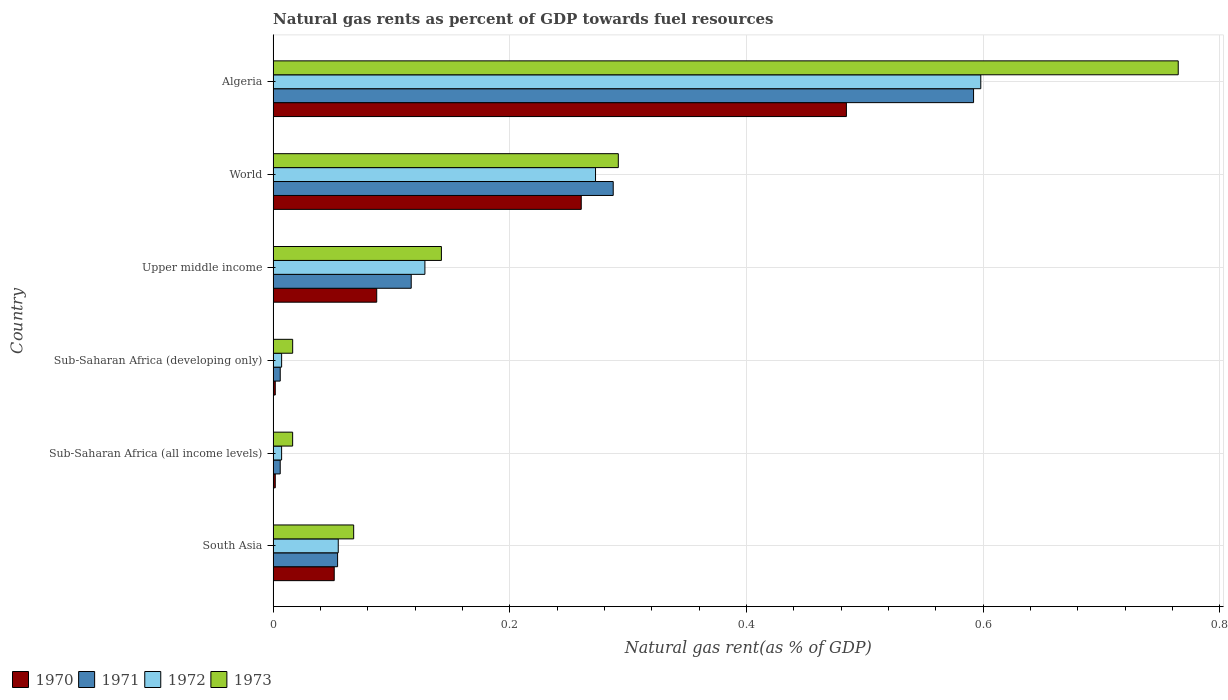How many different coloured bars are there?
Ensure brevity in your answer.  4. How many groups of bars are there?
Offer a terse response. 6. Are the number of bars per tick equal to the number of legend labels?
Your answer should be very brief. Yes. Are the number of bars on each tick of the Y-axis equal?
Offer a terse response. Yes. How many bars are there on the 6th tick from the top?
Ensure brevity in your answer.  4. How many bars are there on the 4th tick from the bottom?
Offer a very short reply. 4. In how many cases, is the number of bars for a given country not equal to the number of legend labels?
Make the answer very short. 0. What is the natural gas rent in 1970 in Sub-Saharan Africa (all income levels)?
Your response must be concise. 0. Across all countries, what is the maximum natural gas rent in 1970?
Ensure brevity in your answer.  0.48. Across all countries, what is the minimum natural gas rent in 1973?
Offer a terse response. 0.02. In which country was the natural gas rent in 1973 maximum?
Offer a very short reply. Algeria. In which country was the natural gas rent in 1971 minimum?
Offer a terse response. Sub-Saharan Africa (all income levels). What is the total natural gas rent in 1971 in the graph?
Provide a succinct answer. 1.06. What is the difference between the natural gas rent in 1970 in South Asia and that in Upper middle income?
Your answer should be compact. -0.04. What is the difference between the natural gas rent in 1973 in Sub-Saharan Africa (all income levels) and the natural gas rent in 1970 in Sub-Saharan Africa (developing only)?
Your answer should be very brief. 0.01. What is the average natural gas rent in 1973 per country?
Make the answer very short. 0.22. What is the difference between the natural gas rent in 1970 and natural gas rent in 1971 in Sub-Saharan Africa (all income levels)?
Provide a short and direct response. -0. In how many countries, is the natural gas rent in 1970 greater than 0.7200000000000001 %?
Ensure brevity in your answer.  0. What is the ratio of the natural gas rent in 1971 in Upper middle income to that in World?
Give a very brief answer. 0.41. What is the difference between the highest and the second highest natural gas rent in 1971?
Your answer should be very brief. 0.3. What is the difference between the highest and the lowest natural gas rent in 1973?
Ensure brevity in your answer.  0.75. Is it the case that in every country, the sum of the natural gas rent in 1973 and natural gas rent in 1972 is greater than the sum of natural gas rent in 1970 and natural gas rent in 1971?
Provide a short and direct response. No. What does the 2nd bar from the top in Sub-Saharan Africa (developing only) represents?
Keep it short and to the point. 1972. What does the 1st bar from the bottom in Sub-Saharan Africa (developing only) represents?
Your response must be concise. 1970. Is it the case that in every country, the sum of the natural gas rent in 1972 and natural gas rent in 1971 is greater than the natural gas rent in 1970?
Your answer should be compact. Yes. How many countries are there in the graph?
Your answer should be compact. 6. What is the difference between two consecutive major ticks on the X-axis?
Make the answer very short. 0.2. Are the values on the major ticks of X-axis written in scientific E-notation?
Your answer should be compact. No. Does the graph contain any zero values?
Offer a terse response. No. What is the title of the graph?
Your response must be concise. Natural gas rents as percent of GDP towards fuel resources. Does "1969" appear as one of the legend labels in the graph?
Ensure brevity in your answer.  No. What is the label or title of the X-axis?
Give a very brief answer. Natural gas rent(as % of GDP). What is the label or title of the Y-axis?
Make the answer very short. Country. What is the Natural gas rent(as % of GDP) in 1970 in South Asia?
Make the answer very short. 0.05. What is the Natural gas rent(as % of GDP) of 1971 in South Asia?
Keep it short and to the point. 0.05. What is the Natural gas rent(as % of GDP) of 1972 in South Asia?
Provide a succinct answer. 0.06. What is the Natural gas rent(as % of GDP) in 1973 in South Asia?
Make the answer very short. 0.07. What is the Natural gas rent(as % of GDP) in 1970 in Sub-Saharan Africa (all income levels)?
Your response must be concise. 0. What is the Natural gas rent(as % of GDP) in 1971 in Sub-Saharan Africa (all income levels)?
Make the answer very short. 0.01. What is the Natural gas rent(as % of GDP) of 1972 in Sub-Saharan Africa (all income levels)?
Give a very brief answer. 0.01. What is the Natural gas rent(as % of GDP) in 1973 in Sub-Saharan Africa (all income levels)?
Make the answer very short. 0.02. What is the Natural gas rent(as % of GDP) in 1970 in Sub-Saharan Africa (developing only)?
Ensure brevity in your answer.  0. What is the Natural gas rent(as % of GDP) in 1971 in Sub-Saharan Africa (developing only)?
Ensure brevity in your answer.  0.01. What is the Natural gas rent(as % of GDP) in 1972 in Sub-Saharan Africa (developing only)?
Give a very brief answer. 0.01. What is the Natural gas rent(as % of GDP) of 1973 in Sub-Saharan Africa (developing only)?
Your response must be concise. 0.02. What is the Natural gas rent(as % of GDP) of 1970 in Upper middle income?
Your answer should be very brief. 0.09. What is the Natural gas rent(as % of GDP) in 1971 in Upper middle income?
Your answer should be compact. 0.12. What is the Natural gas rent(as % of GDP) of 1972 in Upper middle income?
Keep it short and to the point. 0.13. What is the Natural gas rent(as % of GDP) in 1973 in Upper middle income?
Provide a succinct answer. 0.14. What is the Natural gas rent(as % of GDP) of 1970 in World?
Your answer should be very brief. 0.26. What is the Natural gas rent(as % of GDP) in 1971 in World?
Keep it short and to the point. 0.29. What is the Natural gas rent(as % of GDP) in 1972 in World?
Provide a succinct answer. 0.27. What is the Natural gas rent(as % of GDP) in 1973 in World?
Provide a succinct answer. 0.29. What is the Natural gas rent(as % of GDP) of 1970 in Algeria?
Your answer should be very brief. 0.48. What is the Natural gas rent(as % of GDP) in 1971 in Algeria?
Your response must be concise. 0.59. What is the Natural gas rent(as % of GDP) of 1972 in Algeria?
Give a very brief answer. 0.6. What is the Natural gas rent(as % of GDP) in 1973 in Algeria?
Ensure brevity in your answer.  0.76. Across all countries, what is the maximum Natural gas rent(as % of GDP) of 1970?
Keep it short and to the point. 0.48. Across all countries, what is the maximum Natural gas rent(as % of GDP) of 1971?
Make the answer very short. 0.59. Across all countries, what is the maximum Natural gas rent(as % of GDP) of 1972?
Make the answer very short. 0.6. Across all countries, what is the maximum Natural gas rent(as % of GDP) in 1973?
Your response must be concise. 0.76. Across all countries, what is the minimum Natural gas rent(as % of GDP) in 1970?
Offer a very short reply. 0. Across all countries, what is the minimum Natural gas rent(as % of GDP) of 1971?
Provide a succinct answer. 0.01. Across all countries, what is the minimum Natural gas rent(as % of GDP) of 1972?
Give a very brief answer. 0.01. Across all countries, what is the minimum Natural gas rent(as % of GDP) of 1973?
Provide a short and direct response. 0.02. What is the total Natural gas rent(as % of GDP) of 1970 in the graph?
Give a very brief answer. 0.89. What is the total Natural gas rent(as % of GDP) of 1972 in the graph?
Keep it short and to the point. 1.07. What is the total Natural gas rent(as % of GDP) in 1973 in the graph?
Your answer should be compact. 1.3. What is the difference between the Natural gas rent(as % of GDP) of 1970 in South Asia and that in Sub-Saharan Africa (all income levels)?
Offer a terse response. 0.05. What is the difference between the Natural gas rent(as % of GDP) in 1971 in South Asia and that in Sub-Saharan Africa (all income levels)?
Offer a very short reply. 0.05. What is the difference between the Natural gas rent(as % of GDP) of 1972 in South Asia and that in Sub-Saharan Africa (all income levels)?
Provide a succinct answer. 0.05. What is the difference between the Natural gas rent(as % of GDP) of 1973 in South Asia and that in Sub-Saharan Africa (all income levels)?
Provide a short and direct response. 0.05. What is the difference between the Natural gas rent(as % of GDP) in 1970 in South Asia and that in Sub-Saharan Africa (developing only)?
Give a very brief answer. 0.05. What is the difference between the Natural gas rent(as % of GDP) in 1971 in South Asia and that in Sub-Saharan Africa (developing only)?
Give a very brief answer. 0.05. What is the difference between the Natural gas rent(as % of GDP) of 1972 in South Asia and that in Sub-Saharan Africa (developing only)?
Provide a short and direct response. 0.05. What is the difference between the Natural gas rent(as % of GDP) in 1973 in South Asia and that in Sub-Saharan Africa (developing only)?
Your response must be concise. 0.05. What is the difference between the Natural gas rent(as % of GDP) in 1970 in South Asia and that in Upper middle income?
Provide a succinct answer. -0.04. What is the difference between the Natural gas rent(as % of GDP) of 1971 in South Asia and that in Upper middle income?
Your answer should be very brief. -0.06. What is the difference between the Natural gas rent(as % of GDP) in 1972 in South Asia and that in Upper middle income?
Offer a very short reply. -0.07. What is the difference between the Natural gas rent(as % of GDP) of 1973 in South Asia and that in Upper middle income?
Offer a terse response. -0.07. What is the difference between the Natural gas rent(as % of GDP) in 1970 in South Asia and that in World?
Your response must be concise. -0.21. What is the difference between the Natural gas rent(as % of GDP) in 1971 in South Asia and that in World?
Provide a succinct answer. -0.23. What is the difference between the Natural gas rent(as % of GDP) in 1972 in South Asia and that in World?
Provide a succinct answer. -0.22. What is the difference between the Natural gas rent(as % of GDP) of 1973 in South Asia and that in World?
Your answer should be compact. -0.22. What is the difference between the Natural gas rent(as % of GDP) of 1970 in South Asia and that in Algeria?
Keep it short and to the point. -0.43. What is the difference between the Natural gas rent(as % of GDP) of 1971 in South Asia and that in Algeria?
Your response must be concise. -0.54. What is the difference between the Natural gas rent(as % of GDP) of 1972 in South Asia and that in Algeria?
Keep it short and to the point. -0.54. What is the difference between the Natural gas rent(as % of GDP) of 1973 in South Asia and that in Algeria?
Make the answer very short. -0.7. What is the difference between the Natural gas rent(as % of GDP) of 1972 in Sub-Saharan Africa (all income levels) and that in Sub-Saharan Africa (developing only)?
Provide a succinct answer. -0. What is the difference between the Natural gas rent(as % of GDP) of 1970 in Sub-Saharan Africa (all income levels) and that in Upper middle income?
Ensure brevity in your answer.  -0.09. What is the difference between the Natural gas rent(as % of GDP) of 1971 in Sub-Saharan Africa (all income levels) and that in Upper middle income?
Ensure brevity in your answer.  -0.11. What is the difference between the Natural gas rent(as % of GDP) of 1972 in Sub-Saharan Africa (all income levels) and that in Upper middle income?
Provide a succinct answer. -0.12. What is the difference between the Natural gas rent(as % of GDP) of 1973 in Sub-Saharan Africa (all income levels) and that in Upper middle income?
Ensure brevity in your answer.  -0.13. What is the difference between the Natural gas rent(as % of GDP) of 1970 in Sub-Saharan Africa (all income levels) and that in World?
Make the answer very short. -0.26. What is the difference between the Natural gas rent(as % of GDP) of 1971 in Sub-Saharan Africa (all income levels) and that in World?
Provide a succinct answer. -0.28. What is the difference between the Natural gas rent(as % of GDP) of 1972 in Sub-Saharan Africa (all income levels) and that in World?
Provide a succinct answer. -0.27. What is the difference between the Natural gas rent(as % of GDP) in 1973 in Sub-Saharan Africa (all income levels) and that in World?
Give a very brief answer. -0.28. What is the difference between the Natural gas rent(as % of GDP) in 1970 in Sub-Saharan Africa (all income levels) and that in Algeria?
Offer a very short reply. -0.48. What is the difference between the Natural gas rent(as % of GDP) of 1971 in Sub-Saharan Africa (all income levels) and that in Algeria?
Provide a short and direct response. -0.59. What is the difference between the Natural gas rent(as % of GDP) in 1972 in Sub-Saharan Africa (all income levels) and that in Algeria?
Provide a succinct answer. -0.59. What is the difference between the Natural gas rent(as % of GDP) in 1973 in Sub-Saharan Africa (all income levels) and that in Algeria?
Make the answer very short. -0.75. What is the difference between the Natural gas rent(as % of GDP) of 1970 in Sub-Saharan Africa (developing only) and that in Upper middle income?
Your answer should be very brief. -0.09. What is the difference between the Natural gas rent(as % of GDP) in 1971 in Sub-Saharan Africa (developing only) and that in Upper middle income?
Offer a very short reply. -0.11. What is the difference between the Natural gas rent(as % of GDP) in 1972 in Sub-Saharan Africa (developing only) and that in Upper middle income?
Make the answer very short. -0.12. What is the difference between the Natural gas rent(as % of GDP) in 1973 in Sub-Saharan Africa (developing only) and that in Upper middle income?
Offer a very short reply. -0.13. What is the difference between the Natural gas rent(as % of GDP) in 1970 in Sub-Saharan Africa (developing only) and that in World?
Your answer should be compact. -0.26. What is the difference between the Natural gas rent(as % of GDP) in 1971 in Sub-Saharan Africa (developing only) and that in World?
Offer a terse response. -0.28. What is the difference between the Natural gas rent(as % of GDP) in 1972 in Sub-Saharan Africa (developing only) and that in World?
Keep it short and to the point. -0.27. What is the difference between the Natural gas rent(as % of GDP) of 1973 in Sub-Saharan Africa (developing only) and that in World?
Keep it short and to the point. -0.28. What is the difference between the Natural gas rent(as % of GDP) in 1970 in Sub-Saharan Africa (developing only) and that in Algeria?
Offer a very short reply. -0.48. What is the difference between the Natural gas rent(as % of GDP) of 1971 in Sub-Saharan Africa (developing only) and that in Algeria?
Make the answer very short. -0.59. What is the difference between the Natural gas rent(as % of GDP) in 1972 in Sub-Saharan Africa (developing only) and that in Algeria?
Keep it short and to the point. -0.59. What is the difference between the Natural gas rent(as % of GDP) of 1973 in Sub-Saharan Africa (developing only) and that in Algeria?
Your answer should be very brief. -0.75. What is the difference between the Natural gas rent(as % of GDP) in 1970 in Upper middle income and that in World?
Ensure brevity in your answer.  -0.17. What is the difference between the Natural gas rent(as % of GDP) of 1971 in Upper middle income and that in World?
Make the answer very short. -0.17. What is the difference between the Natural gas rent(as % of GDP) in 1972 in Upper middle income and that in World?
Offer a very short reply. -0.14. What is the difference between the Natural gas rent(as % of GDP) in 1973 in Upper middle income and that in World?
Provide a succinct answer. -0.15. What is the difference between the Natural gas rent(as % of GDP) in 1970 in Upper middle income and that in Algeria?
Provide a succinct answer. -0.4. What is the difference between the Natural gas rent(as % of GDP) of 1971 in Upper middle income and that in Algeria?
Your response must be concise. -0.48. What is the difference between the Natural gas rent(as % of GDP) of 1972 in Upper middle income and that in Algeria?
Your answer should be compact. -0.47. What is the difference between the Natural gas rent(as % of GDP) in 1973 in Upper middle income and that in Algeria?
Provide a short and direct response. -0.62. What is the difference between the Natural gas rent(as % of GDP) in 1970 in World and that in Algeria?
Ensure brevity in your answer.  -0.22. What is the difference between the Natural gas rent(as % of GDP) in 1971 in World and that in Algeria?
Keep it short and to the point. -0.3. What is the difference between the Natural gas rent(as % of GDP) in 1972 in World and that in Algeria?
Ensure brevity in your answer.  -0.33. What is the difference between the Natural gas rent(as % of GDP) in 1973 in World and that in Algeria?
Give a very brief answer. -0.47. What is the difference between the Natural gas rent(as % of GDP) of 1970 in South Asia and the Natural gas rent(as % of GDP) of 1971 in Sub-Saharan Africa (all income levels)?
Ensure brevity in your answer.  0.05. What is the difference between the Natural gas rent(as % of GDP) in 1970 in South Asia and the Natural gas rent(as % of GDP) in 1972 in Sub-Saharan Africa (all income levels)?
Give a very brief answer. 0.04. What is the difference between the Natural gas rent(as % of GDP) of 1970 in South Asia and the Natural gas rent(as % of GDP) of 1973 in Sub-Saharan Africa (all income levels)?
Your response must be concise. 0.04. What is the difference between the Natural gas rent(as % of GDP) of 1971 in South Asia and the Natural gas rent(as % of GDP) of 1972 in Sub-Saharan Africa (all income levels)?
Your response must be concise. 0.05. What is the difference between the Natural gas rent(as % of GDP) of 1971 in South Asia and the Natural gas rent(as % of GDP) of 1973 in Sub-Saharan Africa (all income levels)?
Your answer should be compact. 0.04. What is the difference between the Natural gas rent(as % of GDP) of 1972 in South Asia and the Natural gas rent(as % of GDP) of 1973 in Sub-Saharan Africa (all income levels)?
Ensure brevity in your answer.  0.04. What is the difference between the Natural gas rent(as % of GDP) of 1970 in South Asia and the Natural gas rent(as % of GDP) of 1971 in Sub-Saharan Africa (developing only)?
Offer a very short reply. 0.05. What is the difference between the Natural gas rent(as % of GDP) in 1970 in South Asia and the Natural gas rent(as % of GDP) in 1972 in Sub-Saharan Africa (developing only)?
Ensure brevity in your answer.  0.04. What is the difference between the Natural gas rent(as % of GDP) in 1970 in South Asia and the Natural gas rent(as % of GDP) in 1973 in Sub-Saharan Africa (developing only)?
Your answer should be very brief. 0.04. What is the difference between the Natural gas rent(as % of GDP) in 1971 in South Asia and the Natural gas rent(as % of GDP) in 1972 in Sub-Saharan Africa (developing only)?
Offer a very short reply. 0.05. What is the difference between the Natural gas rent(as % of GDP) of 1971 in South Asia and the Natural gas rent(as % of GDP) of 1973 in Sub-Saharan Africa (developing only)?
Make the answer very short. 0.04. What is the difference between the Natural gas rent(as % of GDP) in 1972 in South Asia and the Natural gas rent(as % of GDP) in 1973 in Sub-Saharan Africa (developing only)?
Provide a short and direct response. 0.04. What is the difference between the Natural gas rent(as % of GDP) of 1970 in South Asia and the Natural gas rent(as % of GDP) of 1971 in Upper middle income?
Ensure brevity in your answer.  -0.07. What is the difference between the Natural gas rent(as % of GDP) of 1970 in South Asia and the Natural gas rent(as % of GDP) of 1972 in Upper middle income?
Provide a succinct answer. -0.08. What is the difference between the Natural gas rent(as % of GDP) of 1970 in South Asia and the Natural gas rent(as % of GDP) of 1973 in Upper middle income?
Provide a short and direct response. -0.09. What is the difference between the Natural gas rent(as % of GDP) of 1971 in South Asia and the Natural gas rent(as % of GDP) of 1972 in Upper middle income?
Your answer should be compact. -0.07. What is the difference between the Natural gas rent(as % of GDP) of 1971 in South Asia and the Natural gas rent(as % of GDP) of 1973 in Upper middle income?
Give a very brief answer. -0.09. What is the difference between the Natural gas rent(as % of GDP) of 1972 in South Asia and the Natural gas rent(as % of GDP) of 1973 in Upper middle income?
Your response must be concise. -0.09. What is the difference between the Natural gas rent(as % of GDP) in 1970 in South Asia and the Natural gas rent(as % of GDP) in 1971 in World?
Ensure brevity in your answer.  -0.24. What is the difference between the Natural gas rent(as % of GDP) in 1970 in South Asia and the Natural gas rent(as % of GDP) in 1972 in World?
Your answer should be very brief. -0.22. What is the difference between the Natural gas rent(as % of GDP) of 1970 in South Asia and the Natural gas rent(as % of GDP) of 1973 in World?
Provide a succinct answer. -0.24. What is the difference between the Natural gas rent(as % of GDP) of 1971 in South Asia and the Natural gas rent(as % of GDP) of 1972 in World?
Your response must be concise. -0.22. What is the difference between the Natural gas rent(as % of GDP) in 1971 in South Asia and the Natural gas rent(as % of GDP) in 1973 in World?
Provide a succinct answer. -0.24. What is the difference between the Natural gas rent(as % of GDP) of 1972 in South Asia and the Natural gas rent(as % of GDP) of 1973 in World?
Your answer should be compact. -0.24. What is the difference between the Natural gas rent(as % of GDP) in 1970 in South Asia and the Natural gas rent(as % of GDP) in 1971 in Algeria?
Your response must be concise. -0.54. What is the difference between the Natural gas rent(as % of GDP) in 1970 in South Asia and the Natural gas rent(as % of GDP) in 1972 in Algeria?
Your answer should be compact. -0.55. What is the difference between the Natural gas rent(as % of GDP) in 1970 in South Asia and the Natural gas rent(as % of GDP) in 1973 in Algeria?
Offer a terse response. -0.71. What is the difference between the Natural gas rent(as % of GDP) in 1971 in South Asia and the Natural gas rent(as % of GDP) in 1972 in Algeria?
Give a very brief answer. -0.54. What is the difference between the Natural gas rent(as % of GDP) in 1971 in South Asia and the Natural gas rent(as % of GDP) in 1973 in Algeria?
Keep it short and to the point. -0.71. What is the difference between the Natural gas rent(as % of GDP) in 1972 in South Asia and the Natural gas rent(as % of GDP) in 1973 in Algeria?
Make the answer very short. -0.71. What is the difference between the Natural gas rent(as % of GDP) of 1970 in Sub-Saharan Africa (all income levels) and the Natural gas rent(as % of GDP) of 1971 in Sub-Saharan Africa (developing only)?
Ensure brevity in your answer.  -0. What is the difference between the Natural gas rent(as % of GDP) of 1970 in Sub-Saharan Africa (all income levels) and the Natural gas rent(as % of GDP) of 1972 in Sub-Saharan Africa (developing only)?
Ensure brevity in your answer.  -0.01. What is the difference between the Natural gas rent(as % of GDP) of 1970 in Sub-Saharan Africa (all income levels) and the Natural gas rent(as % of GDP) of 1973 in Sub-Saharan Africa (developing only)?
Offer a very short reply. -0.01. What is the difference between the Natural gas rent(as % of GDP) in 1971 in Sub-Saharan Africa (all income levels) and the Natural gas rent(as % of GDP) in 1972 in Sub-Saharan Africa (developing only)?
Provide a succinct answer. -0. What is the difference between the Natural gas rent(as % of GDP) of 1971 in Sub-Saharan Africa (all income levels) and the Natural gas rent(as % of GDP) of 1973 in Sub-Saharan Africa (developing only)?
Your answer should be very brief. -0.01. What is the difference between the Natural gas rent(as % of GDP) of 1972 in Sub-Saharan Africa (all income levels) and the Natural gas rent(as % of GDP) of 1973 in Sub-Saharan Africa (developing only)?
Give a very brief answer. -0.01. What is the difference between the Natural gas rent(as % of GDP) of 1970 in Sub-Saharan Africa (all income levels) and the Natural gas rent(as % of GDP) of 1971 in Upper middle income?
Make the answer very short. -0.11. What is the difference between the Natural gas rent(as % of GDP) in 1970 in Sub-Saharan Africa (all income levels) and the Natural gas rent(as % of GDP) in 1972 in Upper middle income?
Your answer should be very brief. -0.13. What is the difference between the Natural gas rent(as % of GDP) in 1970 in Sub-Saharan Africa (all income levels) and the Natural gas rent(as % of GDP) in 1973 in Upper middle income?
Ensure brevity in your answer.  -0.14. What is the difference between the Natural gas rent(as % of GDP) in 1971 in Sub-Saharan Africa (all income levels) and the Natural gas rent(as % of GDP) in 1972 in Upper middle income?
Your answer should be very brief. -0.12. What is the difference between the Natural gas rent(as % of GDP) of 1971 in Sub-Saharan Africa (all income levels) and the Natural gas rent(as % of GDP) of 1973 in Upper middle income?
Make the answer very short. -0.14. What is the difference between the Natural gas rent(as % of GDP) of 1972 in Sub-Saharan Africa (all income levels) and the Natural gas rent(as % of GDP) of 1973 in Upper middle income?
Provide a short and direct response. -0.14. What is the difference between the Natural gas rent(as % of GDP) in 1970 in Sub-Saharan Africa (all income levels) and the Natural gas rent(as % of GDP) in 1971 in World?
Offer a terse response. -0.29. What is the difference between the Natural gas rent(as % of GDP) of 1970 in Sub-Saharan Africa (all income levels) and the Natural gas rent(as % of GDP) of 1972 in World?
Ensure brevity in your answer.  -0.27. What is the difference between the Natural gas rent(as % of GDP) in 1970 in Sub-Saharan Africa (all income levels) and the Natural gas rent(as % of GDP) in 1973 in World?
Give a very brief answer. -0.29. What is the difference between the Natural gas rent(as % of GDP) of 1971 in Sub-Saharan Africa (all income levels) and the Natural gas rent(as % of GDP) of 1972 in World?
Provide a succinct answer. -0.27. What is the difference between the Natural gas rent(as % of GDP) in 1971 in Sub-Saharan Africa (all income levels) and the Natural gas rent(as % of GDP) in 1973 in World?
Your response must be concise. -0.29. What is the difference between the Natural gas rent(as % of GDP) of 1972 in Sub-Saharan Africa (all income levels) and the Natural gas rent(as % of GDP) of 1973 in World?
Ensure brevity in your answer.  -0.28. What is the difference between the Natural gas rent(as % of GDP) of 1970 in Sub-Saharan Africa (all income levels) and the Natural gas rent(as % of GDP) of 1971 in Algeria?
Offer a very short reply. -0.59. What is the difference between the Natural gas rent(as % of GDP) of 1970 in Sub-Saharan Africa (all income levels) and the Natural gas rent(as % of GDP) of 1972 in Algeria?
Provide a short and direct response. -0.6. What is the difference between the Natural gas rent(as % of GDP) in 1970 in Sub-Saharan Africa (all income levels) and the Natural gas rent(as % of GDP) in 1973 in Algeria?
Ensure brevity in your answer.  -0.76. What is the difference between the Natural gas rent(as % of GDP) of 1971 in Sub-Saharan Africa (all income levels) and the Natural gas rent(as % of GDP) of 1972 in Algeria?
Give a very brief answer. -0.59. What is the difference between the Natural gas rent(as % of GDP) in 1971 in Sub-Saharan Africa (all income levels) and the Natural gas rent(as % of GDP) in 1973 in Algeria?
Ensure brevity in your answer.  -0.76. What is the difference between the Natural gas rent(as % of GDP) in 1972 in Sub-Saharan Africa (all income levels) and the Natural gas rent(as % of GDP) in 1973 in Algeria?
Keep it short and to the point. -0.76. What is the difference between the Natural gas rent(as % of GDP) of 1970 in Sub-Saharan Africa (developing only) and the Natural gas rent(as % of GDP) of 1971 in Upper middle income?
Give a very brief answer. -0.11. What is the difference between the Natural gas rent(as % of GDP) of 1970 in Sub-Saharan Africa (developing only) and the Natural gas rent(as % of GDP) of 1972 in Upper middle income?
Offer a very short reply. -0.13. What is the difference between the Natural gas rent(as % of GDP) of 1970 in Sub-Saharan Africa (developing only) and the Natural gas rent(as % of GDP) of 1973 in Upper middle income?
Offer a very short reply. -0.14. What is the difference between the Natural gas rent(as % of GDP) in 1971 in Sub-Saharan Africa (developing only) and the Natural gas rent(as % of GDP) in 1972 in Upper middle income?
Offer a terse response. -0.12. What is the difference between the Natural gas rent(as % of GDP) in 1971 in Sub-Saharan Africa (developing only) and the Natural gas rent(as % of GDP) in 1973 in Upper middle income?
Offer a terse response. -0.14. What is the difference between the Natural gas rent(as % of GDP) of 1972 in Sub-Saharan Africa (developing only) and the Natural gas rent(as % of GDP) of 1973 in Upper middle income?
Keep it short and to the point. -0.14. What is the difference between the Natural gas rent(as % of GDP) of 1970 in Sub-Saharan Africa (developing only) and the Natural gas rent(as % of GDP) of 1971 in World?
Offer a very short reply. -0.29. What is the difference between the Natural gas rent(as % of GDP) in 1970 in Sub-Saharan Africa (developing only) and the Natural gas rent(as % of GDP) in 1972 in World?
Provide a succinct answer. -0.27. What is the difference between the Natural gas rent(as % of GDP) of 1970 in Sub-Saharan Africa (developing only) and the Natural gas rent(as % of GDP) of 1973 in World?
Your answer should be compact. -0.29. What is the difference between the Natural gas rent(as % of GDP) in 1971 in Sub-Saharan Africa (developing only) and the Natural gas rent(as % of GDP) in 1972 in World?
Ensure brevity in your answer.  -0.27. What is the difference between the Natural gas rent(as % of GDP) in 1971 in Sub-Saharan Africa (developing only) and the Natural gas rent(as % of GDP) in 1973 in World?
Keep it short and to the point. -0.29. What is the difference between the Natural gas rent(as % of GDP) in 1972 in Sub-Saharan Africa (developing only) and the Natural gas rent(as % of GDP) in 1973 in World?
Your answer should be very brief. -0.28. What is the difference between the Natural gas rent(as % of GDP) in 1970 in Sub-Saharan Africa (developing only) and the Natural gas rent(as % of GDP) in 1971 in Algeria?
Offer a very short reply. -0.59. What is the difference between the Natural gas rent(as % of GDP) of 1970 in Sub-Saharan Africa (developing only) and the Natural gas rent(as % of GDP) of 1972 in Algeria?
Ensure brevity in your answer.  -0.6. What is the difference between the Natural gas rent(as % of GDP) of 1970 in Sub-Saharan Africa (developing only) and the Natural gas rent(as % of GDP) of 1973 in Algeria?
Your answer should be compact. -0.76. What is the difference between the Natural gas rent(as % of GDP) of 1971 in Sub-Saharan Africa (developing only) and the Natural gas rent(as % of GDP) of 1972 in Algeria?
Keep it short and to the point. -0.59. What is the difference between the Natural gas rent(as % of GDP) in 1971 in Sub-Saharan Africa (developing only) and the Natural gas rent(as % of GDP) in 1973 in Algeria?
Offer a very short reply. -0.76. What is the difference between the Natural gas rent(as % of GDP) in 1972 in Sub-Saharan Africa (developing only) and the Natural gas rent(as % of GDP) in 1973 in Algeria?
Give a very brief answer. -0.76. What is the difference between the Natural gas rent(as % of GDP) in 1970 in Upper middle income and the Natural gas rent(as % of GDP) in 1971 in World?
Your answer should be very brief. -0.2. What is the difference between the Natural gas rent(as % of GDP) of 1970 in Upper middle income and the Natural gas rent(as % of GDP) of 1972 in World?
Make the answer very short. -0.18. What is the difference between the Natural gas rent(as % of GDP) in 1970 in Upper middle income and the Natural gas rent(as % of GDP) in 1973 in World?
Your answer should be very brief. -0.2. What is the difference between the Natural gas rent(as % of GDP) in 1971 in Upper middle income and the Natural gas rent(as % of GDP) in 1972 in World?
Your response must be concise. -0.16. What is the difference between the Natural gas rent(as % of GDP) in 1971 in Upper middle income and the Natural gas rent(as % of GDP) in 1973 in World?
Offer a terse response. -0.17. What is the difference between the Natural gas rent(as % of GDP) in 1972 in Upper middle income and the Natural gas rent(as % of GDP) in 1973 in World?
Give a very brief answer. -0.16. What is the difference between the Natural gas rent(as % of GDP) of 1970 in Upper middle income and the Natural gas rent(as % of GDP) of 1971 in Algeria?
Provide a short and direct response. -0.5. What is the difference between the Natural gas rent(as % of GDP) in 1970 in Upper middle income and the Natural gas rent(as % of GDP) in 1972 in Algeria?
Provide a short and direct response. -0.51. What is the difference between the Natural gas rent(as % of GDP) in 1970 in Upper middle income and the Natural gas rent(as % of GDP) in 1973 in Algeria?
Your answer should be compact. -0.68. What is the difference between the Natural gas rent(as % of GDP) in 1971 in Upper middle income and the Natural gas rent(as % of GDP) in 1972 in Algeria?
Ensure brevity in your answer.  -0.48. What is the difference between the Natural gas rent(as % of GDP) in 1971 in Upper middle income and the Natural gas rent(as % of GDP) in 1973 in Algeria?
Offer a terse response. -0.65. What is the difference between the Natural gas rent(as % of GDP) in 1972 in Upper middle income and the Natural gas rent(as % of GDP) in 1973 in Algeria?
Your answer should be compact. -0.64. What is the difference between the Natural gas rent(as % of GDP) of 1970 in World and the Natural gas rent(as % of GDP) of 1971 in Algeria?
Provide a succinct answer. -0.33. What is the difference between the Natural gas rent(as % of GDP) of 1970 in World and the Natural gas rent(as % of GDP) of 1972 in Algeria?
Keep it short and to the point. -0.34. What is the difference between the Natural gas rent(as % of GDP) of 1970 in World and the Natural gas rent(as % of GDP) of 1973 in Algeria?
Make the answer very short. -0.5. What is the difference between the Natural gas rent(as % of GDP) in 1971 in World and the Natural gas rent(as % of GDP) in 1972 in Algeria?
Provide a succinct answer. -0.31. What is the difference between the Natural gas rent(as % of GDP) in 1971 in World and the Natural gas rent(as % of GDP) in 1973 in Algeria?
Offer a very short reply. -0.48. What is the difference between the Natural gas rent(as % of GDP) in 1972 in World and the Natural gas rent(as % of GDP) in 1973 in Algeria?
Give a very brief answer. -0.49. What is the average Natural gas rent(as % of GDP) in 1970 per country?
Make the answer very short. 0.15. What is the average Natural gas rent(as % of GDP) of 1971 per country?
Ensure brevity in your answer.  0.18. What is the average Natural gas rent(as % of GDP) in 1972 per country?
Give a very brief answer. 0.18. What is the average Natural gas rent(as % of GDP) in 1973 per country?
Provide a short and direct response. 0.22. What is the difference between the Natural gas rent(as % of GDP) of 1970 and Natural gas rent(as % of GDP) of 1971 in South Asia?
Your answer should be very brief. -0. What is the difference between the Natural gas rent(as % of GDP) of 1970 and Natural gas rent(as % of GDP) of 1972 in South Asia?
Make the answer very short. -0. What is the difference between the Natural gas rent(as % of GDP) in 1970 and Natural gas rent(as % of GDP) in 1973 in South Asia?
Provide a succinct answer. -0.02. What is the difference between the Natural gas rent(as % of GDP) of 1971 and Natural gas rent(as % of GDP) of 1972 in South Asia?
Your response must be concise. -0. What is the difference between the Natural gas rent(as % of GDP) of 1971 and Natural gas rent(as % of GDP) of 1973 in South Asia?
Keep it short and to the point. -0.01. What is the difference between the Natural gas rent(as % of GDP) of 1972 and Natural gas rent(as % of GDP) of 1973 in South Asia?
Keep it short and to the point. -0.01. What is the difference between the Natural gas rent(as % of GDP) of 1970 and Natural gas rent(as % of GDP) of 1971 in Sub-Saharan Africa (all income levels)?
Your answer should be compact. -0. What is the difference between the Natural gas rent(as % of GDP) of 1970 and Natural gas rent(as % of GDP) of 1972 in Sub-Saharan Africa (all income levels)?
Ensure brevity in your answer.  -0.01. What is the difference between the Natural gas rent(as % of GDP) in 1970 and Natural gas rent(as % of GDP) in 1973 in Sub-Saharan Africa (all income levels)?
Provide a succinct answer. -0.01. What is the difference between the Natural gas rent(as % of GDP) in 1971 and Natural gas rent(as % of GDP) in 1972 in Sub-Saharan Africa (all income levels)?
Offer a terse response. -0. What is the difference between the Natural gas rent(as % of GDP) in 1971 and Natural gas rent(as % of GDP) in 1973 in Sub-Saharan Africa (all income levels)?
Provide a short and direct response. -0.01. What is the difference between the Natural gas rent(as % of GDP) of 1972 and Natural gas rent(as % of GDP) of 1973 in Sub-Saharan Africa (all income levels)?
Your response must be concise. -0.01. What is the difference between the Natural gas rent(as % of GDP) in 1970 and Natural gas rent(as % of GDP) in 1971 in Sub-Saharan Africa (developing only)?
Provide a short and direct response. -0. What is the difference between the Natural gas rent(as % of GDP) in 1970 and Natural gas rent(as % of GDP) in 1972 in Sub-Saharan Africa (developing only)?
Provide a succinct answer. -0.01. What is the difference between the Natural gas rent(as % of GDP) of 1970 and Natural gas rent(as % of GDP) of 1973 in Sub-Saharan Africa (developing only)?
Give a very brief answer. -0.01. What is the difference between the Natural gas rent(as % of GDP) of 1971 and Natural gas rent(as % of GDP) of 1972 in Sub-Saharan Africa (developing only)?
Your answer should be very brief. -0. What is the difference between the Natural gas rent(as % of GDP) of 1971 and Natural gas rent(as % of GDP) of 1973 in Sub-Saharan Africa (developing only)?
Your response must be concise. -0.01. What is the difference between the Natural gas rent(as % of GDP) in 1972 and Natural gas rent(as % of GDP) in 1973 in Sub-Saharan Africa (developing only)?
Give a very brief answer. -0.01. What is the difference between the Natural gas rent(as % of GDP) of 1970 and Natural gas rent(as % of GDP) of 1971 in Upper middle income?
Provide a short and direct response. -0.03. What is the difference between the Natural gas rent(as % of GDP) of 1970 and Natural gas rent(as % of GDP) of 1972 in Upper middle income?
Offer a very short reply. -0.04. What is the difference between the Natural gas rent(as % of GDP) of 1970 and Natural gas rent(as % of GDP) of 1973 in Upper middle income?
Provide a succinct answer. -0.05. What is the difference between the Natural gas rent(as % of GDP) of 1971 and Natural gas rent(as % of GDP) of 1972 in Upper middle income?
Ensure brevity in your answer.  -0.01. What is the difference between the Natural gas rent(as % of GDP) in 1971 and Natural gas rent(as % of GDP) in 1973 in Upper middle income?
Keep it short and to the point. -0.03. What is the difference between the Natural gas rent(as % of GDP) of 1972 and Natural gas rent(as % of GDP) of 1973 in Upper middle income?
Provide a short and direct response. -0.01. What is the difference between the Natural gas rent(as % of GDP) in 1970 and Natural gas rent(as % of GDP) in 1971 in World?
Provide a short and direct response. -0.03. What is the difference between the Natural gas rent(as % of GDP) of 1970 and Natural gas rent(as % of GDP) of 1972 in World?
Make the answer very short. -0.01. What is the difference between the Natural gas rent(as % of GDP) of 1970 and Natural gas rent(as % of GDP) of 1973 in World?
Your answer should be compact. -0.03. What is the difference between the Natural gas rent(as % of GDP) of 1971 and Natural gas rent(as % of GDP) of 1972 in World?
Offer a very short reply. 0.01. What is the difference between the Natural gas rent(as % of GDP) of 1971 and Natural gas rent(as % of GDP) of 1973 in World?
Give a very brief answer. -0. What is the difference between the Natural gas rent(as % of GDP) of 1972 and Natural gas rent(as % of GDP) of 1973 in World?
Give a very brief answer. -0.02. What is the difference between the Natural gas rent(as % of GDP) in 1970 and Natural gas rent(as % of GDP) in 1971 in Algeria?
Your answer should be very brief. -0.11. What is the difference between the Natural gas rent(as % of GDP) in 1970 and Natural gas rent(as % of GDP) in 1972 in Algeria?
Make the answer very short. -0.11. What is the difference between the Natural gas rent(as % of GDP) of 1970 and Natural gas rent(as % of GDP) of 1973 in Algeria?
Your answer should be very brief. -0.28. What is the difference between the Natural gas rent(as % of GDP) of 1971 and Natural gas rent(as % of GDP) of 1972 in Algeria?
Your answer should be very brief. -0.01. What is the difference between the Natural gas rent(as % of GDP) of 1971 and Natural gas rent(as % of GDP) of 1973 in Algeria?
Your answer should be compact. -0.17. What is the difference between the Natural gas rent(as % of GDP) of 1972 and Natural gas rent(as % of GDP) of 1973 in Algeria?
Ensure brevity in your answer.  -0.17. What is the ratio of the Natural gas rent(as % of GDP) of 1970 in South Asia to that in Sub-Saharan Africa (all income levels)?
Give a very brief answer. 28.57. What is the ratio of the Natural gas rent(as % of GDP) in 1971 in South Asia to that in Sub-Saharan Africa (all income levels)?
Your response must be concise. 9.07. What is the ratio of the Natural gas rent(as % of GDP) of 1972 in South Asia to that in Sub-Saharan Africa (all income levels)?
Give a very brief answer. 7.67. What is the ratio of the Natural gas rent(as % of GDP) of 1973 in South Asia to that in Sub-Saharan Africa (all income levels)?
Make the answer very short. 4.13. What is the ratio of the Natural gas rent(as % of GDP) in 1970 in South Asia to that in Sub-Saharan Africa (developing only)?
Ensure brevity in your answer.  28.53. What is the ratio of the Natural gas rent(as % of GDP) of 1971 in South Asia to that in Sub-Saharan Africa (developing only)?
Provide a short and direct response. 9.06. What is the ratio of the Natural gas rent(as % of GDP) in 1972 in South Asia to that in Sub-Saharan Africa (developing only)?
Your response must be concise. 7.66. What is the ratio of the Natural gas rent(as % of GDP) in 1973 in South Asia to that in Sub-Saharan Africa (developing only)?
Your response must be concise. 4.12. What is the ratio of the Natural gas rent(as % of GDP) of 1970 in South Asia to that in Upper middle income?
Provide a short and direct response. 0.59. What is the ratio of the Natural gas rent(as % of GDP) of 1971 in South Asia to that in Upper middle income?
Make the answer very short. 0.47. What is the ratio of the Natural gas rent(as % of GDP) of 1972 in South Asia to that in Upper middle income?
Your answer should be very brief. 0.43. What is the ratio of the Natural gas rent(as % of GDP) of 1973 in South Asia to that in Upper middle income?
Ensure brevity in your answer.  0.48. What is the ratio of the Natural gas rent(as % of GDP) of 1970 in South Asia to that in World?
Ensure brevity in your answer.  0.2. What is the ratio of the Natural gas rent(as % of GDP) in 1971 in South Asia to that in World?
Ensure brevity in your answer.  0.19. What is the ratio of the Natural gas rent(as % of GDP) in 1972 in South Asia to that in World?
Your answer should be very brief. 0.2. What is the ratio of the Natural gas rent(as % of GDP) in 1973 in South Asia to that in World?
Keep it short and to the point. 0.23. What is the ratio of the Natural gas rent(as % of GDP) in 1970 in South Asia to that in Algeria?
Your response must be concise. 0.11. What is the ratio of the Natural gas rent(as % of GDP) in 1971 in South Asia to that in Algeria?
Make the answer very short. 0.09. What is the ratio of the Natural gas rent(as % of GDP) in 1972 in South Asia to that in Algeria?
Make the answer very short. 0.09. What is the ratio of the Natural gas rent(as % of GDP) in 1973 in South Asia to that in Algeria?
Give a very brief answer. 0.09. What is the ratio of the Natural gas rent(as % of GDP) of 1971 in Sub-Saharan Africa (all income levels) to that in Sub-Saharan Africa (developing only)?
Make the answer very short. 1. What is the ratio of the Natural gas rent(as % of GDP) of 1972 in Sub-Saharan Africa (all income levels) to that in Sub-Saharan Africa (developing only)?
Offer a very short reply. 1. What is the ratio of the Natural gas rent(as % of GDP) of 1973 in Sub-Saharan Africa (all income levels) to that in Sub-Saharan Africa (developing only)?
Keep it short and to the point. 1. What is the ratio of the Natural gas rent(as % of GDP) of 1970 in Sub-Saharan Africa (all income levels) to that in Upper middle income?
Make the answer very short. 0.02. What is the ratio of the Natural gas rent(as % of GDP) of 1971 in Sub-Saharan Africa (all income levels) to that in Upper middle income?
Offer a very short reply. 0.05. What is the ratio of the Natural gas rent(as % of GDP) of 1972 in Sub-Saharan Africa (all income levels) to that in Upper middle income?
Offer a very short reply. 0.06. What is the ratio of the Natural gas rent(as % of GDP) of 1973 in Sub-Saharan Africa (all income levels) to that in Upper middle income?
Your answer should be compact. 0.12. What is the ratio of the Natural gas rent(as % of GDP) of 1970 in Sub-Saharan Africa (all income levels) to that in World?
Provide a short and direct response. 0.01. What is the ratio of the Natural gas rent(as % of GDP) of 1971 in Sub-Saharan Africa (all income levels) to that in World?
Offer a terse response. 0.02. What is the ratio of the Natural gas rent(as % of GDP) of 1972 in Sub-Saharan Africa (all income levels) to that in World?
Make the answer very short. 0.03. What is the ratio of the Natural gas rent(as % of GDP) of 1973 in Sub-Saharan Africa (all income levels) to that in World?
Your response must be concise. 0.06. What is the ratio of the Natural gas rent(as % of GDP) of 1970 in Sub-Saharan Africa (all income levels) to that in Algeria?
Your answer should be compact. 0. What is the ratio of the Natural gas rent(as % of GDP) of 1971 in Sub-Saharan Africa (all income levels) to that in Algeria?
Ensure brevity in your answer.  0.01. What is the ratio of the Natural gas rent(as % of GDP) in 1972 in Sub-Saharan Africa (all income levels) to that in Algeria?
Offer a terse response. 0.01. What is the ratio of the Natural gas rent(as % of GDP) in 1973 in Sub-Saharan Africa (all income levels) to that in Algeria?
Your answer should be compact. 0.02. What is the ratio of the Natural gas rent(as % of GDP) in 1970 in Sub-Saharan Africa (developing only) to that in Upper middle income?
Provide a succinct answer. 0.02. What is the ratio of the Natural gas rent(as % of GDP) in 1971 in Sub-Saharan Africa (developing only) to that in Upper middle income?
Your answer should be very brief. 0.05. What is the ratio of the Natural gas rent(as % of GDP) in 1972 in Sub-Saharan Africa (developing only) to that in Upper middle income?
Your answer should be compact. 0.06. What is the ratio of the Natural gas rent(as % of GDP) of 1973 in Sub-Saharan Africa (developing only) to that in Upper middle income?
Make the answer very short. 0.12. What is the ratio of the Natural gas rent(as % of GDP) in 1970 in Sub-Saharan Africa (developing only) to that in World?
Provide a succinct answer. 0.01. What is the ratio of the Natural gas rent(as % of GDP) of 1971 in Sub-Saharan Africa (developing only) to that in World?
Keep it short and to the point. 0.02. What is the ratio of the Natural gas rent(as % of GDP) of 1972 in Sub-Saharan Africa (developing only) to that in World?
Your answer should be very brief. 0.03. What is the ratio of the Natural gas rent(as % of GDP) of 1973 in Sub-Saharan Africa (developing only) to that in World?
Your answer should be very brief. 0.06. What is the ratio of the Natural gas rent(as % of GDP) in 1970 in Sub-Saharan Africa (developing only) to that in Algeria?
Your answer should be very brief. 0. What is the ratio of the Natural gas rent(as % of GDP) of 1971 in Sub-Saharan Africa (developing only) to that in Algeria?
Ensure brevity in your answer.  0.01. What is the ratio of the Natural gas rent(as % of GDP) of 1972 in Sub-Saharan Africa (developing only) to that in Algeria?
Provide a short and direct response. 0.01. What is the ratio of the Natural gas rent(as % of GDP) in 1973 in Sub-Saharan Africa (developing only) to that in Algeria?
Offer a terse response. 0.02. What is the ratio of the Natural gas rent(as % of GDP) in 1970 in Upper middle income to that in World?
Keep it short and to the point. 0.34. What is the ratio of the Natural gas rent(as % of GDP) in 1971 in Upper middle income to that in World?
Give a very brief answer. 0.41. What is the ratio of the Natural gas rent(as % of GDP) of 1972 in Upper middle income to that in World?
Offer a terse response. 0.47. What is the ratio of the Natural gas rent(as % of GDP) of 1973 in Upper middle income to that in World?
Offer a very short reply. 0.49. What is the ratio of the Natural gas rent(as % of GDP) of 1970 in Upper middle income to that in Algeria?
Your answer should be compact. 0.18. What is the ratio of the Natural gas rent(as % of GDP) of 1971 in Upper middle income to that in Algeria?
Provide a succinct answer. 0.2. What is the ratio of the Natural gas rent(as % of GDP) in 1972 in Upper middle income to that in Algeria?
Your response must be concise. 0.21. What is the ratio of the Natural gas rent(as % of GDP) in 1973 in Upper middle income to that in Algeria?
Your answer should be compact. 0.19. What is the ratio of the Natural gas rent(as % of GDP) of 1970 in World to that in Algeria?
Your answer should be very brief. 0.54. What is the ratio of the Natural gas rent(as % of GDP) in 1971 in World to that in Algeria?
Your answer should be compact. 0.49. What is the ratio of the Natural gas rent(as % of GDP) of 1972 in World to that in Algeria?
Offer a terse response. 0.46. What is the ratio of the Natural gas rent(as % of GDP) of 1973 in World to that in Algeria?
Your answer should be very brief. 0.38. What is the difference between the highest and the second highest Natural gas rent(as % of GDP) in 1970?
Your answer should be very brief. 0.22. What is the difference between the highest and the second highest Natural gas rent(as % of GDP) of 1971?
Keep it short and to the point. 0.3. What is the difference between the highest and the second highest Natural gas rent(as % of GDP) of 1972?
Make the answer very short. 0.33. What is the difference between the highest and the second highest Natural gas rent(as % of GDP) of 1973?
Make the answer very short. 0.47. What is the difference between the highest and the lowest Natural gas rent(as % of GDP) of 1970?
Offer a terse response. 0.48. What is the difference between the highest and the lowest Natural gas rent(as % of GDP) of 1971?
Offer a terse response. 0.59. What is the difference between the highest and the lowest Natural gas rent(as % of GDP) in 1972?
Offer a very short reply. 0.59. What is the difference between the highest and the lowest Natural gas rent(as % of GDP) of 1973?
Ensure brevity in your answer.  0.75. 